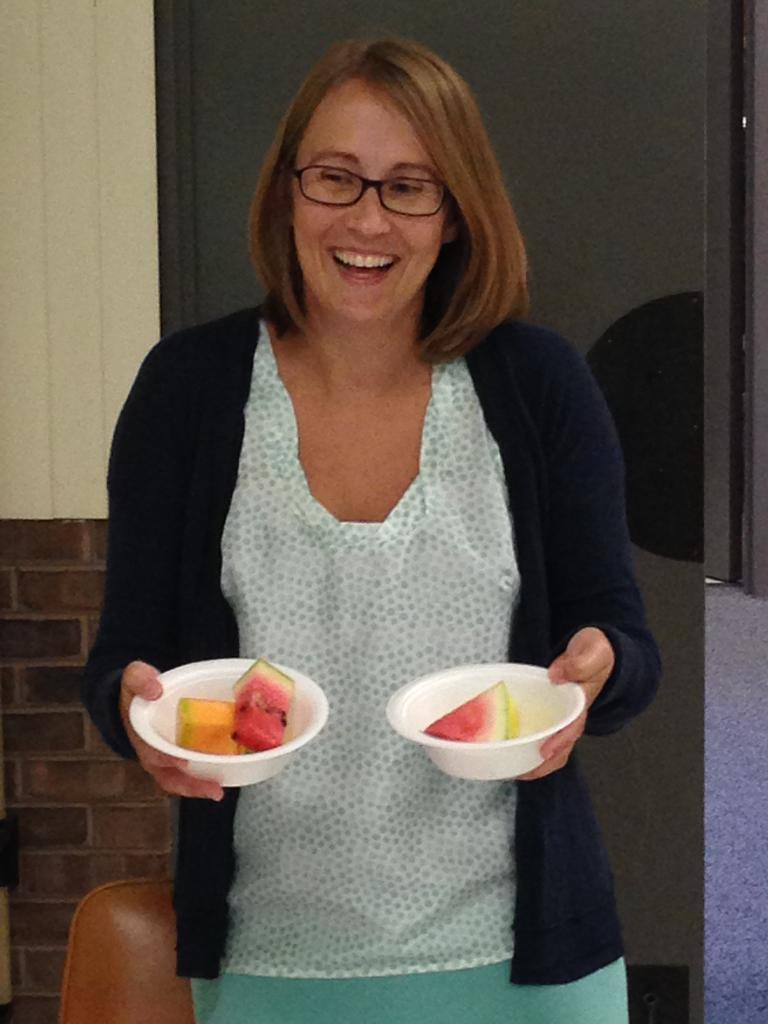In one or two sentences, can you explain what this image depicts? In this picture we can observe a woman holding two bowls with some fruits in them. The woman is smiling and wearing spectacles. In the background there is a wall. 